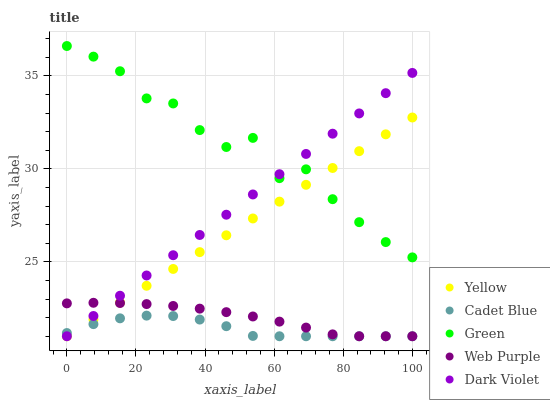Does Cadet Blue have the minimum area under the curve?
Answer yes or no. Yes. Does Green have the maximum area under the curve?
Answer yes or no. Yes. Does Green have the minimum area under the curve?
Answer yes or no. No. Does Cadet Blue have the maximum area under the curve?
Answer yes or no. No. Is Yellow the smoothest?
Answer yes or no. Yes. Is Green the roughest?
Answer yes or no. Yes. Is Cadet Blue the smoothest?
Answer yes or no. No. Is Cadet Blue the roughest?
Answer yes or no. No. Does Web Purple have the lowest value?
Answer yes or no. Yes. Does Green have the lowest value?
Answer yes or no. No. Does Green have the highest value?
Answer yes or no. Yes. Does Cadet Blue have the highest value?
Answer yes or no. No. Is Web Purple less than Green?
Answer yes or no. Yes. Is Green greater than Web Purple?
Answer yes or no. Yes. Does Yellow intersect Web Purple?
Answer yes or no. Yes. Is Yellow less than Web Purple?
Answer yes or no. No. Is Yellow greater than Web Purple?
Answer yes or no. No. Does Web Purple intersect Green?
Answer yes or no. No. 